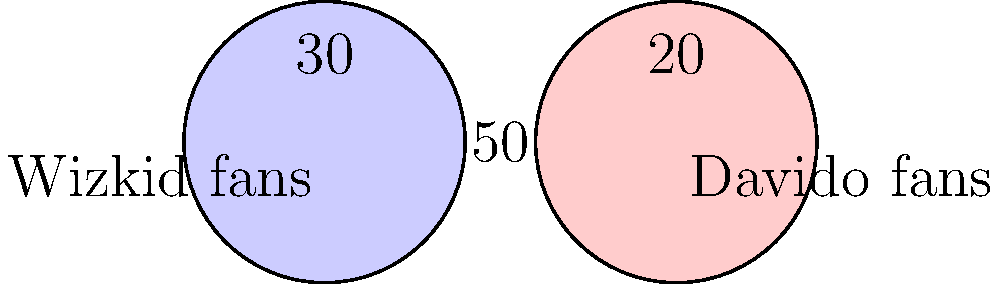In the Venn diagram above, which represents the fan demographics of Wizkid and Davido, what percentage of the total fanbase are exclusively Wizkid fans? To solve this problem, let's break it down step-by-step:

1. First, we need to identify the total number of fans:
   Exclusive Wizkid fans + Exclusive Davido fans + Fans of both = Total fans
   30 + 20 + 50 = 100

2. Now, we know that the total fanbase is 100.

3. The question asks for the percentage of fans who are exclusively Wizkid fans.

4. From the diagram, we can see that there are 30 exclusive Wizkid fans.

5. To calculate the percentage, we use the formula:
   $\text{Percentage} = \frac{\text{Part}}{\text{Whole}} \times 100\%$

6. Plugging in our values:
   $\text{Percentage} = \frac{30}{100} \times 100\% = 30\%$

Therefore, 30% of the total fanbase are exclusively Wizkid fans.
Answer: 30% 